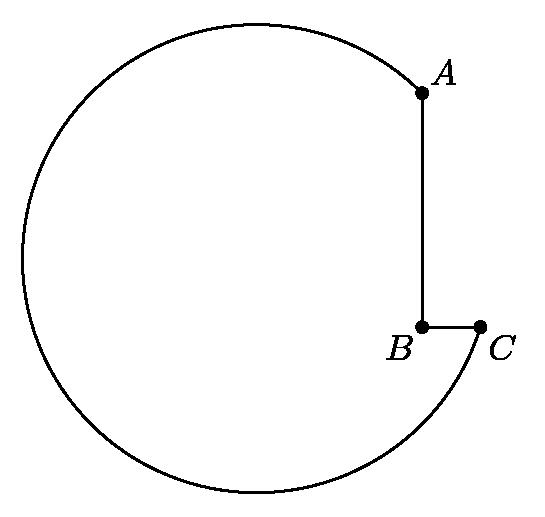How could the dimensions of this tool impact its functionality in the machine shop? The dimensions of this tool, particularly the radius and lengths of segments AB and BC, directly influence its suitability for specific tasks. A larger radius allows for broader scope of work, while the dimensions of AB and BC determine the preciseness of the tool's fit and functionality with smaller components or finer tasks. 